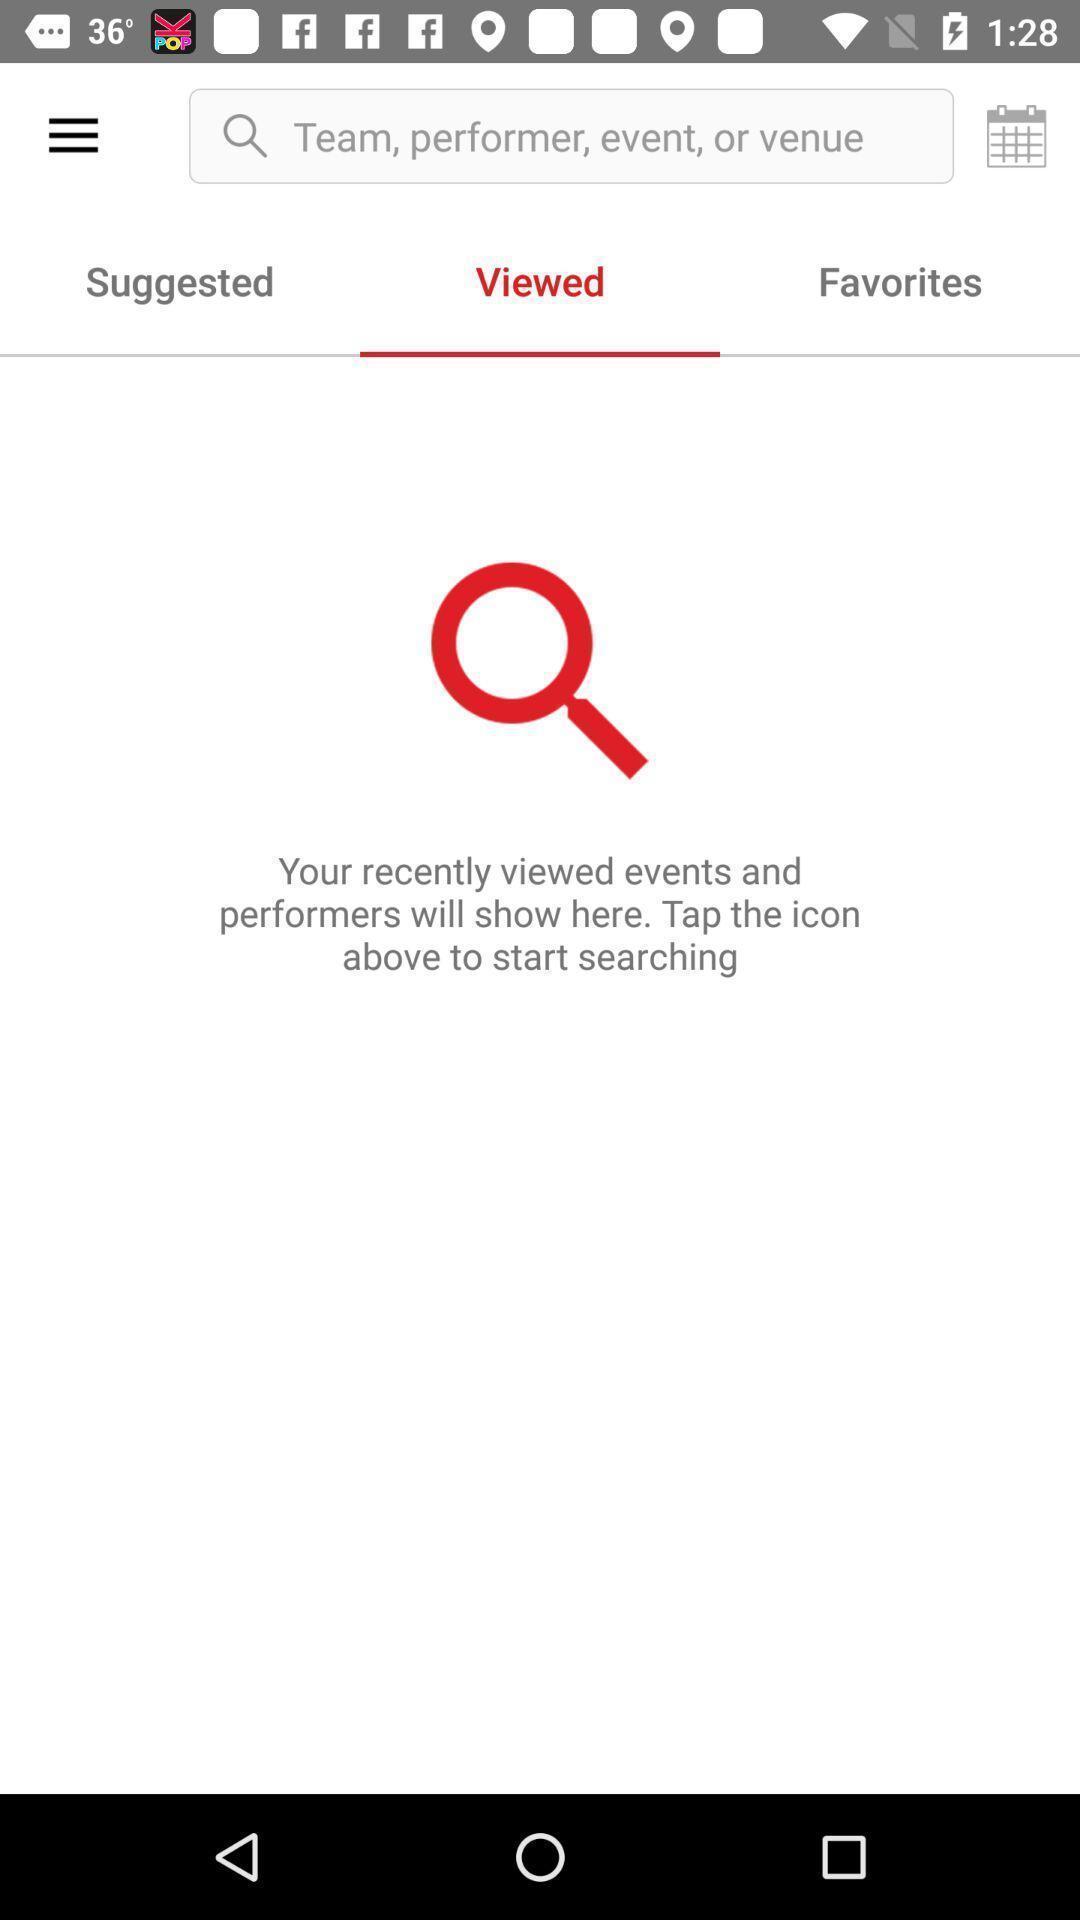What details can you identify in this image? Viewed page. 